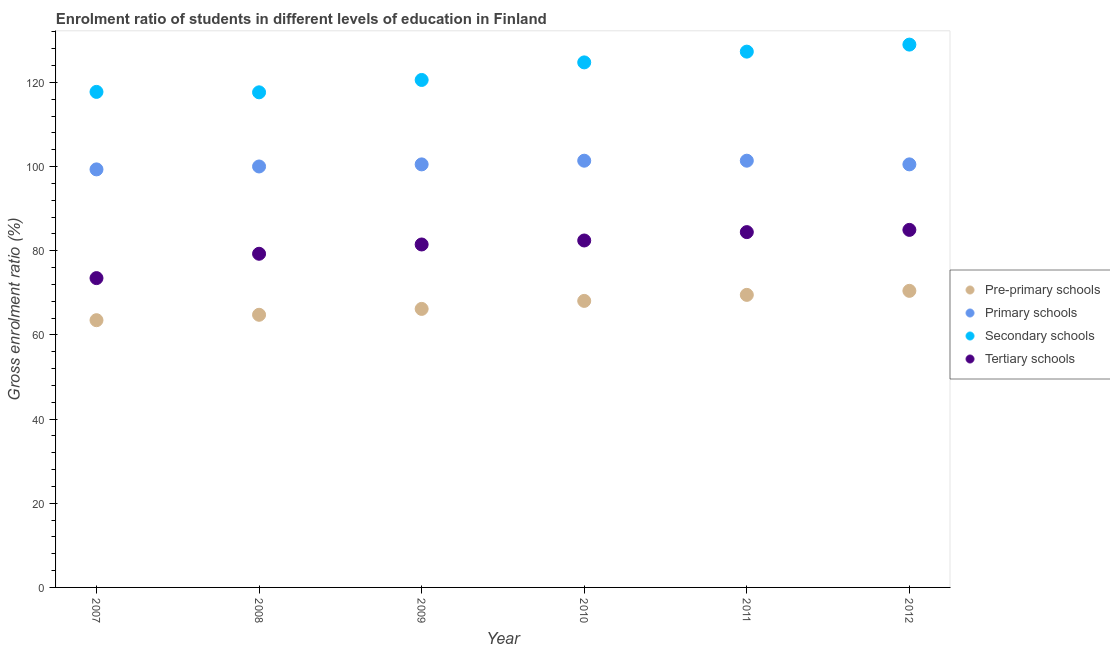How many different coloured dotlines are there?
Provide a short and direct response. 4. Is the number of dotlines equal to the number of legend labels?
Offer a terse response. Yes. What is the gross enrolment ratio in pre-primary schools in 2011?
Offer a terse response. 69.52. Across all years, what is the maximum gross enrolment ratio in pre-primary schools?
Offer a terse response. 70.47. Across all years, what is the minimum gross enrolment ratio in tertiary schools?
Ensure brevity in your answer.  73.5. In which year was the gross enrolment ratio in tertiary schools minimum?
Your answer should be very brief. 2007. What is the total gross enrolment ratio in tertiary schools in the graph?
Your response must be concise. 486.11. What is the difference between the gross enrolment ratio in pre-primary schools in 2007 and that in 2012?
Provide a succinct answer. -6.97. What is the difference between the gross enrolment ratio in primary schools in 2007 and the gross enrolment ratio in tertiary schools in 2010?
Offer a terse response. 16.9. What is the average gross enrolment ratio in primary schools per year?
Keep it short and to the point. 100.54. In the year 2011, what is the difference between the gross enrolment ratio in secondary schools and gross enrolment ratio in pre-primary schools?
Make the answer very short. 57.8. What is the ratio of the gross enrolment ratio in primary schools in 2010 to that in 2012?
Your answer should be very brief. 1.01. Is the gross enrolment ratio in secondary schools in 2010 less than that in 2011?
Give a very brief answer. Yes. Is the difference between the gross enrolment ratio in secondary schools in 2008 and 2009 greater than the difference between the gross enrolment ratio in primary schools in 2008 and 2009?
Give a very brief answer. No. What is the difference between the highest and the second highest gross enrolment ratio in tertiary schools?
Offer a terse response. 0.53. What is the difference between the highest and the lowest gross enrolment ratio in primary schools?
Ensure brevity in your answer.  2.07. Is it the case that in every year, the sum of the gross enrolment ratio in pre-primary schools and gross enrolment ratio in primary schools is greater than the gross enrolment ratio in secondary schools?
Your answer should be very brief. Yes. Does the gross enrolment ratio in secondary schools monotonically increase over the years?
Ensure brevity in your answer.  No. Is the gross enrolment ratio in secondary schools strictly greater than the gross enrolment ratio in tertiary schools over the years?
Give a very brief answer. Yes. Is the gross enrolment ratio in tertiary schools strictly less than the gross enrolment ratio in secondary schools over the years?
Give a very brief answer. Yes. How many years are there in the graph?
Ensure brevity in your answer.  6. Are the values on the major ticks of Y-axis written in scientific E-notation?
Provide a short and direct response. No. Does the graph contain any zero values?
Provide a short and direct response. No. Does the graph contain grids?
Provide a short and direct response. No. What is the title of the graph?
Your response must be concise. Enrolment ratio of students in different levels of education in Finland. What is the label or title of the Y-axis?
Offer a very short reply. Gross enrolment ratio (%). What is the Gross enrolment ratio (%) of Pre-primary schools in 2007?
Your response must be concise. 63.5. What is the Gross enrolment ratio (%) in Primary schools in 2007?
Make the answer very short. 99.33. What is the Gross enrolment ratio (%) of Secondary schools in 2007?
Offer a terse response. 117.75. What is the Gross enrolment ratio (%) of Tertiary schools in 2007?
Provide a short and direct response. 73.5. What is the Gross enrolment ratio (%) of Pre-primary schools in 2008?
Make the answer very short. 64.79. What is the Gross enrolment ratio (%) of Primary schools in 2008?
Provide a succinct answer. 100.03. What is the Gross enrolment ratio (%) in Secondary schools in 2008?
Offer a terse response. 117.65. What is the Gross enrolment ratio (%) in Tertiary schools in 2008?
Ensure brevity in your answer.  79.28. What is the Gross enrolment ratio (%) of Pre-primary schools in 2009?
Give a very brief answer. 66.18. What is the Gross enrolment ratio (%) in Primary schools in 2009?
Offer a very short reply. 100.52. What is the Gross enrolment ratio (%) of Secondary schools in 2009?
Offer a terse response. 120.58. What is the Gross enrolment ratio (%) in Tertiary schools in 2009?
Your response must be concise. 81.49. What is the Gross enrolment ratio (%) in Pre-primary schools in 2010?
Provide a succinct answer. 68.08. What is the Gross enrolment ratio (%) of Primary schools in 2010?
Make the answer very short. 101.4. What is the Gross enrolment ratio (%) in Secondary schools in 2010?
Your answer should be compact. 124.76. What is the Gross enrolment ratio (%) of Tertiary schools in 2010?
Your answer should be very brief. 82.44. What is the Gross enrolment ratio (%) of Pre-primary schools in 2011?
Keep it short and to the point. 69.52. What is the Gross enrolment ratio (%) of Primary schools in 2011?
Ensure brevity in your answer.  101.4. What is the Gross enrolment ratio (%) in Secondary schools in 2011?
Your response must be concise. 127.32. What is the Gross enrolment ratio (%) in Tertiary schools in 2011?
Provide a succinct answer. 84.43. What is the Gross enrolment ratio (%) in Pre-primary schools in 2012?
Make the answer very short. 70.47. What is the Gross enrolment ratio (%) of Primary schools in 2012?
Keep it short and to the point. 100.53. What is the Gross enrolment ratio (%) of Secondary schools in 2012?
Provide a short and direct response. 128.99. What is the Gross enrolment ratio (%) in Tertiary schools in 2012?
Make the answer very short. 84.96. Across all years, what is the maximum Gross enrolment ratio (%) in Pre-primary schools?
Make the answer very short. 70.47. Across all years, what is the maximum Gross enrolment ratio (%) in Primary schools?
Offer a very short reply. 101.4. Across all years, what is the maximum Gross enrolment ratio (%) in Secondary schools?
Your answer should be very brief. 128.99. Across all years, what is the maximum Gross enrolment ratio (%) in Tertiary schools?
Provide a succinct answer. 84.96. Across all years, what is the minimum Gross enrolment ratio (%) of Pre-primary schools?
Give a very brief answer. 63.5. Across all years, what is the minimum Gross enrolment ratio (%) of Primary schools?
Your answer should be very brief. 99.33. Across all years, what is the minimum Gross enrolment ratio (%) in Secondary schools?
Your response must be concise. 117.65. Across all years, what is the minimum Gross enrolment ratio (%) of Tertiary schools?
Offer a very short reply. 73.5. What is the total Gross enrolment ratio (%) in Pre-primary schools in the graph?
Your response must be concise. 402.54. What is the total Gross enrolment ratio (%) of Primary schools in the graph?
Offer a very short reply. 603.21. What is the total Gross enrolment ratio (%) in Secondary schools in the graph?
Keep it short and to the point. 737.04. What is the total Gross enrolment ratio (%) in Tertiary schools in the graph?
Give a very brief answer. 486.11. What is the difference between the Gross enrolment ratio (%) of Pre-primary schools in 2007 and that in 2008?
Make the answer very short. -1.28. What is the difference between the Gross enrolment ratio (%) of Primary schools in 2007 and that in 2008?
Offer a terse response. -0.69. What is the difference between the Gross enrolment ratio (%) in Secondary schools in 2007 and that in 2008?
Keep it short and to the point. 0.1. What is the difference between the Gross enrolment ratio (%) in Tertiary schools in 2007 and that in 2008?
Provide a short and direct response. -5.78. What is the difference between the Gross enrolment ratio (%) in Pre-primary schools in 2007 and that in 2009?
Offer a terse response. -2.68. What is the difference between the Gross enrolment ratio (%) in Primary schools in 2007 and that in 2009?
Provide a succinct answer. -1.19. What is the difference between the Gross enrolment ratio (%) of Secondary schools in 2007 and that in 2009?
Your response must be concise. -2.84. What is the difference between the Gross enrolment ratio (%) in Tertiary schools in 2007 and that in 2009?
Provide a short and direct response. -7.99. What is the difference between the Gross enrolment ratio (%) in Pre-primary schools in 2007 and that in 2010?
Your answer should be very brief. -4.58. What is the difference between the Gross enrolment ratio (%) of Primary schools in 2007 and that in 2010?
Provide a succinct answer. -2.06. What is the difference between the Gross enrolment ratio (%) of Secondary schools in 2007 and that in 2010?
Your answer should be very brief. -7.01. What is the difference between the Gross enrolment ratio (%) of Tertiary schools in 2007 and that in 2010?
Offer a terse response. -8.94. What is the difference between the Gross enrolment ratio (%) of Pre-primary schools in 2007 and that in 2011?
Offer a very short reply. -6.02. What is the difference between the Gross enrolment ratio (%) of Primary schools in 2007 and that in 2011?
Offer a terse response. -2.07. What is the difference between the Gross enrolment ratio (%) in Secondary schools in 2007 and that in 2011?
Offer a very short reply. -9.57. What is the difference between the Gross enrolment ratio (%) in Tertiary schools in 2007 and that in 2011?
Offer a very short reply. -10.93. What is the difference between the Gross enrolment ratio (%) of Pre-primary schools in 2007 and that in 2012?
Keep it short and to the point. -6.97. What is the difference between the Gross enrolment ratio (%) of Primary schools in 2007 and that in 2012?
Your response must be concise. -1.19. What is the difference between the Gross enrolment ratio (%) in Secondary schools in 2007 and that in 2012?
Your answer should be very brief. -11.24. What is the difference between the Gross enrolment ratio (%) in Tertiary schools in 2007 and that in 2012?
Provide a succinct answer. -11.46. What is the difference between the Gross enrolment ratio (%) of Pre-primary schools in 2008 and that in 2009?
Your response must be concise. -1.4. What is the difference between the Gross enrolment ratio (%) in Primary schools in 2008 and that in 2009?
Your response must be concise. -0.5. What is the difference between the Gross enrolment ratio (%) in Secondary schools in 2008 and that in 2009?
Provide a succinct answer. -2.94. What is the difference between the Gross enrolment ratio (%) in Tertiary schools in 2008 and that in 2009?
Provide a short and direct response. -2.21. What is the difference between the Gross enrolment ratio (%) of Pre-primary schools in 2008 and that in 2010?
Provide a short and direct response. -3.3. What is the difference between the Gross enrolment ratio (%) in Primary schools in 2008 and that in 2010?
Keep it short and to the point. -1.37. What is the difference between the Gross enrolment ratio (%) of Secondary schools in 2008 and that in 2010?
Provide a succinct answer. -7.11. What is the difference between the Gross enrolment ratio (%) in Tertiary schools in 2008 and that in 2010?
Make the answer very short. -3.16. What is the difference between the Gross enrolment ratio (%) in Pre-primary schools in 2008 and that in 2011?
Offer a very short reply. -4.73. What is the difference between the Gross enrolment ratio (%) of Primary schools in 2008 and that in 2011?
Provide a short and direct response. -1.37. What is the difference between the Gross enrolment ratio (%) of Secondary schools in 2008 and that in 2011?
Your response must be concise. -9.67. What is the difference between the Gross enrolment ratio (%) of Tertiary schools in 2008 and that in 2011?
Provide a short and direct response. -5.15. What is the difference between the Gross enrolment ratio (%) of Pre-primary schools in 2008 and that in 2012?
Give a very brief answer. -5.69. What is the difference between the Gross enrolment ratio (%) of Primary schools in 2008 and that in 2012?
Make the answer very short. -0.5. What is the difference between the Gross enrolment ratio (%) of Secondary schools in 2008 and that in 2012?
Your answer should be very brief. -11.34. What is the difference between the Gross enrolment ratio (%) of Tertiary schools in 2008 and that in 2012?
Your response must be concise. -5.68. What is the difference between the Gross enrolment ratio (%) in Pre-primary schools in 2009 and that in 2010?
Your response must be concise. -1.9. What is the difference between the Gross enrolment ratio (%) in Primary schools in 2009 and that in 2010?
Ensure brevity in your answer.  -0.88. What is the difference between the Gross enrolment ratio (%) of Secondary schools in 2009 and that in 2010?
Your answer should be compact. -4.17. What is the difference between the Gross enrolment ratio (%) in Tertiary schools in 2009 and that in 2010?
Give a very brief answer. -0.95. What is the difference between the Gross enrolment ratio (%) in Primary schools in 2009 and that in 2011?
Offer a terse response. -0.88. What is the difference between the Gross enrolment ratio (%) of Secondary schools in 2009 and that in 2011?
Provide a succinct answer. -6.73. What is the difference between the Gross enrolment ratio (%) in Tertiary schools in 2009 and that in 2011?
Your answer should be compact. -2.94. What is the difference between the Gross enrolment ratio (%) of Pre-primary schools in 2009 and that in 2012?
Your response must be concise. -4.29. What is the difference between the Gross enrolment ratio (%) of Primary schools in 2009 and that in 2012?
Offer a terse response. -0. What is the difference between the Gross enrolment ratio (%) in Secondary schools in 2009 and that in 2012?
Your response must be concise. -8.4. What is the difference between the Gross enrolment ratio (%) in Tertiary schools in 2009 and that in 2012?
Keep it short and to the point. -3.47. What is the difference between the Gross enrolment ratio (%) of Pre-primary schools in 2010 and that in 2011?
Ensure brevity in your answer.  -1.43. What is the difference between the Gross enrolment ratio (%) in Primary schools in 2010 and that in 2011?
Make the answer very short. -0. What is the difference between the Gross enrolment ratio (%) in Secondary schools in 2010 and that in 2011?
Provide a succinct answer. -2.56. What is the difference between the Gross enrolment ratio (%) in Tertiary schools in 2010 and that in 2011?
Offer a very short reply. -1.99. What is the difference between the Gross enrolment ratio (%) of Pre-primary schools in 2010 and that in 2012?
Your answer should be very brief. -2.39. What is the difference between the Gross enrolment ratio (%) in Primary schools in 2010 and that in 2012?
Provide a short and direct response. 0.87. What is the difference between the Gross enrolment ratio (%) in Secondary schools in 2010 and that in 2012?
Make the answer very short. -4.23. What is the difference between the Gross enrolment ratio (%) of Tertiary schools in 2010 and that in 2012?
Keep it short and to the point. -2.52. What is the difference between the Gross enrolment ratio (%) in Pre-primary schools in 2011 and that in 2012?
Make the answer very short. -0.96. What is the difference between the Gross enrolment ratio (%) of Primary schools in 2011 and that in 2012?
Give a very brief answer. 0.87. What is the difference between the Gross enrolment ratio (%) in Secondary schools in 2011 and that in 2012?
Make the answer very short. -1.67. What is the difference between the Gross enrolment ratio (%) of Tertiary schools in 2011 and that in 2012?
Provide a short and direct response. -0.53. What is the difference between the Gross enrolment ratio (%) in Pre-primary schools in 2007 and the Gross enrolment ratio (%) in Primary schools in 2008?
Offer a terse response. -36.53. What is the difference between the Gross enrolment ratio (%) in Pre-primary schools in 2007 and the Gross enrolment ratio (%) in Secondary schools in 2008?
Your answer should be very brief. -54.15. What is the difference between the Gross enrolment ratio (%) in Pre-primary schools in 2007 and the Gross enrolment ratio (%) in Tertiary schools in 2008?
Offer a terse response. -15.78. What is the difference between the Gross enrolment ratio (%) of Primary schools in 2007 and the Gross enrolment ratio (%) of Secondary schools in 2008?
Provide a succinct answer. -18.31. What is the difference between the Gross enrolment ratio (%) in Primary schools in 2007 and the Gross enrolment ratio (%) in Tertiary schools in 2008?
Make the answer very short. 20.05. What is the difference between the Gross enrolment ratio (%) of Secondary schools in 2007 and the Gross enrolment ratio (%) of Tertiary schools in 2008?
Keep it short and to the point. 38.47. What is the difference between the Gross enrolment ratio (%) of Pre-primary schools in 2007 and the Gross enrolment ratio (%) of Primary schools in 2009?
Make the answer very short. -37.02. What is the difference between the Gross enrolment ratio (%) of Pre-primary schools in 2007 and the Gross enrolment ratio (%) of Secondary schools in 2009?
Your answer should be compact. -57.08. What is the difference between the Gross enrolment ratio (%) in Pre-primary schools in 2007 and the Gross enrolment ratio (%) in Tertiary schools in 2009?
Give a very brief answer. -17.99. What is the difference between the Gross enrolment ratio (%) in Primary schools in 2007 and the Gross enrolment ratio (%) in Secondary schools in 2009?
Ensure brevity in your answer.  -21.25. What is the difference between the Gross enrolment ratio (%) in Primary schools in 2007 and the Gross enrolment ratio (%) in Tertiary schools in 2009?
Provide a succinct answer. 17.84. What is the difference between the Gross enrolment ratio (%) of Secondary schools in 2007 and the Gross enrolment ratio (%) of Tertiary schools in 2009?
Give a very brief answer. 36.26. What is the difference between the Gross enrolment ratio (%) of Pre-primary schools in 2007 and the Gross enrolment ratio (%) of Primary schools in 2010?
Give a very brief answer. -37.9. What is the difference between the Gross enrolment ratio (%) of Pre-primary schools in 2007 and the Gross enrolment ratio (%) of Secondary schools in 2010?
Make the answer very short. -61.26. What is the difference between the Gross enrolment ratio (%) of Pre-primary schools in 2007 and the Gross enrolment ratio (%) of Tertiary schools in 2010?
Provide a short and direct response. -18.94. What is the difference between the Gross enrolment ratio (%) of Primary schools in 2007 and the Gross enrolment ratio (%) of Secondary schools in 2010?
Make the answer very short. -25.42. What is the difference between the Gross enrolment ratio (%) in Primary schools in 2007 and the Gross enrolment ratio (%) in Tertiary schools in 2010?
Offer a very short reply. 16.9. What is the difference between the Gross enrolment ratio (%) in Secondary schools in 2007 and the Gross enrolment ratio (%) in Tertiary schools in 2010?
Provide a succinct answer. 35.31. What is the difference between the Gross enrolment ratio (%) of Pre-primary schools in 2007 and the Gross enrolment ratio (%) of Primary schools in 2011?
Make the answer very short. -37.9. What is the difference between the Gross enrolment ratio (%) of Pre-primary schools in 2007 and the Gross enrolment ratio (%) of Secondary schools in 2011?
Provide a short and direct response. -63.81. What is the difference between the Gross enrolment ratio (%) of Pre-primary schools in 2007 and the Gross enrolment ratio (%) of Tertiary schools in 2011?
Provide a succinct answer. -20.93. What is the difference between the Gross enrolment ratio (%) in Primary schools in 2007 and the Gross enrolment ratio (%) in Secondary schools in 2011?
Your answer should be very brief. -27.98. What is the difference between the Gross enrolment ratio (%) in Primary schools in 2007 and the Gross enrolment ratio (%) in Tertiary schools in 2011?
Ensure brevity in your answer.  14.9. What is the difference between the Gross enrolment ratio (%) of Secondary schools in 2007 and the Gross enrolment ratio (%) of Tertiary schools in 2011?
Make the answer very short. 33.32. What is the difference between the Gross enrolment ratio (%) in Pre-primary schools in 2007 and the Gross enrolment ratio (%) in Primary schools in 2012?
Ensure brevity in your answer.  -37.03. What is the difference between the Gross enrolment ratio (%) of Pre-primary schools in 2007 and the Gross enrolment ratio (%) of Secondary schools in 2012?
Provide a short and direct response. -65.49. What is the difference between the Gross enrolment ratio (%) in Pre-primary schools in 2007 and the Gross enrolment ratio (%) in Tertiary schools in 2012?
Provide a short and direct response. -21.46. What is the difference between the Gross enrolment ratio (%) of Primary schools in 2007 and the Gross enrolment ratio (%) of Secondary schools in 2012?
Your answer should be compact. -29.65. What is the difference between the Gross enrolment ratio (%) in Primary schools in 2007 and the Gross enrolment ratio (%) in Tertiary schools in 2012?
Give a very brief answer. 14.37. What is the difference between the Gross enrolment ratio (%) in Secondary schools in 2007 and the Gross enrolment ratio (%) in Tertiary schools in 2012?
Offer a terse response. 32.79. What is the difference between the Gross enrolment ratio (%) of Pre-primary schools in 2008 and the Gross enrolment ratio (%) of Primary schools in 2009?
Offer a terse response. -35.74. What is the difference between the Gross enrolment ratio (%) of Pre-primary schools in 2008 and the Gross enrolment ratio (%) of Secondary schools in 2009?
Ensure brevity in your answer.  -55.8. What is the difference between the Gross enrolment ratio (%) in Pre-primary schools in 2008 and the Gross enrolment ratio (%) in Tertiary schools in 2009?
Offer a very short reply. -16.71. What is the difference between the Gross enrolment ratio (%) in Primary schools in 2008 and the Gross enrolment ratio (%) in Secondary schools in 2009?
Ensure brevity in your answer.  -20.56. What is the difference between the Gross enrolment ratio (%) of Primary schools in 2008 and the Gross enrolment ratio (%) of Tertiary schools in 2009?
Give a very brief answer. 18.53. What is the difference between the Gross enrolment ratio (%) in Secondary schools in 2008 and the Gross enrolment ratio (%) in Tertiary schools in 2009?
Your answer should be very brief. 36.16. What is the difference between the Gross enrolment ratio (%) in Pre-primary schools in 2008 and the Gross enrolment ratio (%) in Primary schools in 2010?
Offer a very short reply. -36.61. What is the difference between the Gross enrolment ratio (%) of Pre-primary schools in 2008 and the Gross enrolment ratio (%) of Secondary schools in 2010?
Your answer should be compact. -59.97. What is the difference between the Gross enrolment ratio (%) in Pre-primary schools in 2008 and the Gross enrolment ratio (%) in Tertiary schools in 2010?
Ensure brevity in your answer.  -17.65. What is the difference between the Gross enrolment ratio (%) of Primary schools in 2008 and the Gross enrolment ratio (%) of Secondary schools in 2010?
Ensure brevity in your answer.  -24.73. What is the difference between the Gross enrolment ratio (%) of Primary schools in 2008 and the Gross enrolment ratio (%) of Tertiary schools in 2010?
Ensure brevity in your answer.  17.59. What is the difference between the Gross enrolment ratio (%) of Secondary schools in 2008 and the Gross enrolment ratio (%) of Tertiary schools in 2010?
Offer a terse response. 35.21. What is the difference between the Gross enrolment ratio (%) in Pre-primary schools in 2008 and the Gross enrolment ratio (%) in Primary schools in 2011?
Keep it short and to the point. -36.62. What is the difference between the Gross enrolment ratio (%) in Pre-primary schools in 2008 and the Gross enrolment ratio (%) in Secondary schools in 2011?
Offer a terse response. -62.53. What is the difference between the Gross enrolment ratio (%) in Pre-primary schools in 2008 and the Gross enrolment ratio (%) in Tertiary schools in 2011?
Offer a very short reply. -19.65. What is the difference between the Gross enrolment ratio (%) in Primary schools in 2008 and the Gross enrolment ratio (%) in Secondary schools in 2011?
Offer a terse response. -27.29. What is the difference between the Gross enrolment ratio (%) in Primary schools in 2008 and the Gross enrolment ratio (%) in Tertiary schools in 2011?
Your response must be concise. 15.6. What is the difference between the Gross enrolment ratio (%) of Secondary schools in 2008 and the Gross enrolment ratio (%) of Tertiary schools in 2011?
Offer a very short reply. 33.22. What is the difference between the Gross enrolment ratio (%) of Pre-primary schools in 2008 and the Gross enrolment ratio (%) of Primary schools in 2012?
Your answer should be compact. -35.74. What is the difference between the Gross enrolment ratio (%) in Pre-primary schools in 2008 and the Gross enrolment ratio (%) in Secondary schools in 2012?
Provide a short and direct response. -64.2. What is the difference between the Gross enrolment ratio (%) of Pre-primary schools in 2008 and the Gross enrolment ratio (%) of Tertiary schools in 2012?
Give a very brief answer. -20.18. What is the difference between the Gross enrolment ratio (%) of Primary schools in 2008 and the Gross enrolment ratio (%) of Secondary schools in 2012?
Your answer should be very brief. -28.96. What is the difference between the Gross enrolment ratio (%) in Primary schools in 2008 and the Gross enrolment ratio (%) in Tertiary schools in 2012?
Your response must be concise. 15.07. What is the difference between the Gross enrolment ratio (%) in Secondary schools in 2008 and the Gross enrolment ratio (%) in Tertiary schools in 2012?
Provide a short and direct response. 32.69. What is the difference between the Gross enrolment ratio (%) of Pre-primary schools in 2009 and the Gross enrolment ratio (%) of Primary schools in 2010?
Provide a succinct answer. -35.22. What is the difference between the Gross enrolment ratio (%) in Pre-primary schools in 2009 and the Gross enrolment ratio (%) in Secondary schools in 2010?
Ensure brevity in your answer.  -58.58. What is the difference between the Gross enrolment ratio (%) in Pre-primary schools in 2009 and the Gross enrolment ratio (%) in Tertiary schools in 2010?
Keep it short and to the point. -16.26. What is the difference between the Gross enrolment ratio (%) of Primary schools in 2009 and the Gross enrolment ratio (%) of Secondary schools in 2010?
Offer a very short reply. -24.24. What is the difference between the Gross enrolment ratio (%) of Primary schools in 2009 and the Gross enrolment ratio (%) of Tertiary schools in 2010?
Your answer should be compact. 18.08. What is the difference between the Gross enrolment ratio (%) in Secondary schools in 2009 and the Gross enrolment ratio (%) in Tertiary schools in 2010?
Ensure brevity in your answer.  38.15. What is the difference between the Gross enrolment ratio (%) of Pre-primary schools in 2009 and the Gross enrolment ratio (%) of Primary schools in 2011?
Offer a terse response. -35.22. What is the difference between the Gross enrolment ratio (%) of Pre-primary schools in 2009 and the Gross enrolment ratio (%) of Secondary schools in 2011?
Provide a short and direct response. -61.13. What is the difference between the Gross enrolment ratio (%) in Pre-primary schools in 2009 and the Gross enrolment ratio (%) in Tertiary schools in 2011?
Your answer should be very brief. -18.25. What is the difference between the Gross enrolment ratio (%) of Primary schools in 2009 and the Gross enrolment ratio (%) of Secondary schools in 2011?
Your answer should be very brief. -26.79. What is the difference between the Gross enrolment ratio (%) of Primary schools in 2009 and the Gross enrolment ratio (%) of Tertiary schools in 2011?
Give a very brief answer. 16.09. What is the difference between the Gross enrolment ratio (%) in Secondary schools in 2009 and the Gross enrolment ratio (%) in Tertiary schools in 2011?
Provide a succinct answer. 36.15. What is the difference between the Gross enrolment ratio (%) in Pre-primary schools in 2009 and the Gross enrolment ratio (%) in Primary schools in 2012?
Offer a terse response. -34.34. What is the difference between the Gross enrolment ratio (%) in Pre-primary schools in 2009 and the Gross enrolment ratio (%) in Secondary schools in 2012?
Offer a terse response. -62.8. What is the difference between the Gross enrolment ratio (%) in Pre-primary schools in 2009 and the Gross enrolment ratio (%) in Tertiary schools in 2012?
Offer a terse response. -18.78. What is the difference between the Gross enrolment ratio (%) in Primary schools in 2009 and the Gross enrolment ratio (%) in Secondary schools in 2012?
Give a very brief answer. -28.46. What is the difference between the Gross enrolment ratio (%) of Primary schools in 2009 and the Gross enrolment ratio (%) of Tertiary schools in 2012?
Ensure brevity in your answer.  15.56. What is the difference between the Gross enrolment ratio (%) of Secondary schools in 2009 and the Gross enrolment ratio (%) of Tertiary schools in 2012?
Keep it short and to the point. 35.62. What is the difference between the Gross enrolment ratio (%) in Pre-primary schools in 2010 and the Gross enrolment ratio (%) in Primary schools in 2011?
Give a very brief answer. -33.32. What is the difference between the Gross enrolment ratio (%) of Pre-primary schools in 2010 and the Gross enrolment ratio (%) of Secondary schools in 2011?
Make the answer very short. -59.23. What is the difference between the Gross enrolment ratio (%) of Pre-primary schools in 2010 and the Gross enrolment ratio (%) of Tertiary schools in 2011?
Give a very brief answer. -16.35. What is the difference between the Gross enrolment ratio (%) of Primary schools in 2010 and the Gross enrolment ratio (%) of Secondary schools in 2011?
Ensure brevity in your answer.  -25.92. What is the difference between the Gross enrolment ratio (%) in Primary schools in 2010 and the Gross enrolment ratio (%) in Tertiary schools in 2011?
Your answer should be compact. 16.97. What is the difference between the Gross enrolment ratio (%) in Secondary schools in 2010 and the Gross enrolment ratio (%) in Tertiary schools in 2011?
Keep it short and to the point. 40.33. What is the difference between the Gross enrolment ratio (%) in Pre-primary schools in 2010 and the Gross enrolment ratio (%) in Primary schools in 2012?
Keep it short and to the point. -32.44. What is the difference between the Gross enrolment ratio (%) of Pre-primary schools in 2010 and the Gross enrolment ratio (%) of Secondary schools in 2012?
Keep it short and to the point. -60.9. What is the difference between the Gross enrolment ratio (%) of Pre-primary schools in 2010 and the Gross enrolment ratio (%) of Tertiary schools in 2012?
Give a very brief answer. -16.88. What is the difference between the Gross enrolment ratio (%) in Primary schools in 2010 and the Gross enrolment ratio (%) in Secondary schools in 2012?
Offer a very short reply. -27.59. What is the difference between the Gross enrolment ratio (%) of Primary schools in 2010 and the Gross enrolment ratio (%) of Tertiary schools in 2012?
Make the answer very short. 16.44. What is the difference between the Gross enrolment ratio (%) of Secondary schools in 2010 and the Gross enrolment ratio (%) of Tertiary schools in 2012?
Make the answer very short. 39.8. What is the difference between the Gross enrolment ratio (%) of Pre-primary schools in 2011 and the Gross enrolment ratio (%) of Primary schools in 2012?
Provide a short and direct response. -31.01. What is the difference between the Gross enrolment ratio (%) of Pre-primary schools in 2011 and the Gross enrolment ratio (%) of Secondary schools in 2012?
Your response must be concise. -59.47. What is the difference between the Gross enrolment ratio (%) of Pre-primary schools in 2011 and the Gross enrolment ratio (%) of Tertiary schools in 2012?
Provide a succinct answer. -15.44. What is the difference between the Gross enrolment ratio (%) of Primary schools in 2011 and the Gross enrolment ratio (%) of Secondary schools in 2012?
Give a very brief answer. -27.59. What is the difference between the Gross enrolment ratio (%) of Primary schools in 2011 and the Gross enrolment ratio (%) of Tertiary schools in 2012?
Provide a short and direct response. 16.44. What is the difference between the Gross enrolment ratio (%) in Secondary schools in 2011 and the Gross enrolment ratio (%) in Tertiary schools in 2012?
Offer a very short reply. 42.35. What is the average Gross enrolment ratio (%) of Pre-primary schools per year?
Your answer should be very brief. 67.09. What is the average Gross enrolment ratio (%) in Primary schools per year?
Give a very brief answer. 100.54. What is the average Gross enrolment ratio (%) of Secondary schools per year?
Make the answer very short. 122.84. What is the average Gross enrolment ratio (%) in Tertiary schools per year?
Your answer should be very brief. 81.02. In the year 2007, what is the difference between the Gross enrolment ratio (%) of Pre-primary schools and Gross enrolment ratio (%) of Primary schools?
Ensure brevity in your answer.  -35.83. In the year 2007, what is the difference between the Gross enrolment ratio (%) of Pre-primary schools and Gross enrolment ratio (%) of Secondary schools?
Provide a short and direct response. -54.25. In the year 2007, what is the difference between the Gross enrolment ratio (%) in Pre-primary schools and Gross enrolment ratio (%) in Tertiary schools?
Your answer should be compact. -10. In the year 2007, what is the difference between the Gross enrolment ratio (%) of Primary schools and Gross enrolment ratio (%) of Secondary schools?
Offer a very short reply. -18.41. In the year 2007, what is the difference between the Gross enrolment ratio (%) of Primary schools and Gross enrolment ratio (%) of Tertiary schools?
Offer a terse response. 25.84. In the year 2007, what is the difference between the Gross enrolment ratio (%) of Secondary schools and Gross enrolment ratio (%) of Tertiary schools?
Offer a terse response. 44.25. In the year 2008, what is the difference between the Gross enrolment ratio (%) of Pre-primary schools and Gross enrolment ratio (%) of Primary schools?
Provide a short and direct response. -35.24. In the year 2008, what is the difference between the Gross enrolment ratio (%) of Pre-primary schools and Gross enrolment ratio (%) of Secondary schools?
Offer a very short reply. -52.86. In the year 2008, what is the difference between the Gross enrolment ratio (%) in Pre-primary schools and Gross enrolment ratio (%) in Tertiary schools?
Ensure brevity in your answer.  -14.5. In the year 2008, what is the difference between the Gross enrolment ratio (%) in Primary schools and Gross enrolment ratio (%) in Secondary schools?
Your response must be concise. -17.62. In the year 2008, what is the difference between the Gross enrolment ratio (%) of Primary schools and Gross enrolment ratio (%) of Tertiary schools?
Ensure brevity in your answer.  20.74. In the year 2008, what is the difference between the Gross enrolment ratio (%) of Secondary schools and Gross enrolment ratio (%) of Tertiary schools?
Offer a terse response. 38.36. In the year 2009, what is the difference between the Gross enrolment ratio (%) in Pre-primary schools and Gross enrolment ratio (%) in Primary schools?
Make the answer very short. -34.34. In the year 2009, what is the difference between the Gross enrolment ratio (%) in Pre-primary schools and Gross enrolment ratio (%) in Secondary schools?
Your answer should be very brief. -54.4. In the year 2009, what is the difference between the Gross enrolment ratio (%) of Pre-primary schools and Gross enrolment ratio (%) of Tertiary schools?
Make the answer very short. -15.31. In the year 2009, what is the difference between the Gross enrolment ratio (%) in Primary schools and Gross enrolment ratio (%) in Secondary schools?
Your answer should be compact. -20.06. In the year 2009, what is the difference between the Gross enrolment ratio (%) in Primary schools and Gross enrolment ratio (%) in Tertiary schools?
Your answer should be compact. 19.03. In the year 2009, what is the difference between the Gross enrolment ratio (%) of Secondary schools and Gross enrolment ratio (%) of Tertiary schools?
Keep it short and to the point. 39.09. In the year 2010, what is the difference between the Gross enrolment ratio (%) in Pre-primary schools and Gross enrolment ratio (%) in Primary schools?
Provide a short and direct response. -33.31. In the year 2010, what is the difference between the Gross enrolment ratio (%) of Pre-primary schools and Gross enrolment ratio (%) of Secondary schools?
Offer a very short reply. -56.67. In the year 2010, what is the difference between the Gross enrolment ratio (%) of Pre-primary schools and Gross enrolment ratio (%) of Tertiary schools?
Offer a very short reply. -14.35. In the year 2010, what is the difference between the Gross enrolment ratio (%) of Primary schools and Gross enrolment ratio (%) of Secondary schools?
Provide a short and direct response. -23.36. In the year 2010, what is the difference between the Gross enrolment ratio (%) of Primary schools and Gross enrolment ratio (%) of Tertiary schools?
Your response must be concise. 18.96. In the year 2010, what is the difference between the Gross enrolment ratio (%) in Secondary schools and Gross enrolment ratio (%) in Tertiary schools?
Your answer should be very brief. 42.32. In the year 2011, what is the difference between the Gross enrolment ratio (%) in Pre-primary schools and Gross enrolment ratio (%) in Primary schools?
Offer a terse response. -31.88. In the year 2011, what is the difference between the Gross enrolment ratio (%) in Pre-primary schools and Gross enrolment ratio (%) in Secondary schools?
Provide a short and direct response. -57.8. In the year 2011, what is the difference between the Gross enrolment ratio (%) of Pre-primary schools and Gross enrolment ratio (%) of Tertiary schools?
Make the answer very short. -14.91. In the year 2011, what is the difference between the Gross enrolment ratio (%) in Primary schools and Gross enrolment ratio (%) in Secondary schools?
Offer a terse response. -25.91. In the year 2011, what is the difference between the Gross enrolment ratio (%) in Primary schools and Gross enrolment ratio (%) in Tertiary schools?
Provide a short and direct response. 16.97. In the year 2011, what is the difference between the Gross enrolment ratio (%) in Secondary schools and Gross enrolment ratio (%) in Tertiary schools?
Your response must be concise. 42.88. In the year 2012, what is the difference between the Gross enrolment ratio (%) of Pre-primary schools and Gross enrolment ratio (%) of Primary schools?
Ensure brevity in your answer.  -30.05. In the year 2012, what is the difference between the Gross enrolment ratio (%) in Pre-primary schools and Gross enrolment ratio (%) in Secondary schools?
Make the answer very short. -58.51. In the year 2012, what is the difference between the Gross enrolment ratio (%) of Pre-primary schools and Gross enrolment ratio (%) of Tertiary schools?
Your answer should be compact. -14.49. In the year 2012, what is the difference between the Gross enrolment ratio (%) in Primary schools and Gross enrolment ratio (%) in Secondary schools?
Provide a short and direct response. -28.46. In the year 2012, what is the difference between the Gross enrolment ratio (%) in Primary schools and Gross enrolment ratio (%) in Tertiary schools?
Provide a short and direct response. 15.57. In the year 2012, what is the difference between the Gross enrolment ratio (%) of Secondary schools and Gross enrolment ratio (%) of Tertiary schools?
Provide a succinct answer. 44.03. What is the ratio of the Gross enrolment ratio (%) in Pre-primary schools in 2007 to that in 2008?
Ensure brevity in your answer.  0.98. What is the ratio of the Gross enrolment ratio (%) in Secondary schools in 2007 to that in 2008?
Give a very brief answer. 1. What is the ratio of the Gross enrolment ratio (%) of Tertiary schools in 2007 to that in 2008?
Offer a terse response. 0.93. What is the ratio of the Gross enrolment ratio (%) of Pre-primary schools in 2007 to that in 2009?
Provide a short and direct response. 0.96. What is the ratio of the Gross enrolment ratio (%) in Primary schools in 2007 to that in 2009?
Your response must be concise. 0.99. What is the ratio of the Gross enrolment ratio (%) of Secondary schools in 2007 to that in 2009?
Offer a terse response. 0.98. What is the ratio of the Gross enrolment ratio (%) of Tertiary schools in 2007 to that in 2009?
Make the answer very short. 0.9. What is the ratio of the Gross enrolment ratio (%) of Pre-primary schools in 2007 to that in 2010?
Your response must be concise. 0.93. What is the ratio of the Gross enrolment ratio (%) of Primary schools in 2007 to that in 2010?
Keep it short and to the point. 0.98. What is the ratio of the Gross enrolment ratio (%) of Secondary schools in 2007 to that in 2010?
Give a very brief answer. 0.94. What is the ratio of the Gross enrolment ratio (%) in Tertiary schools in 2007 to that in 2010?
Provide a succinct answer. 0.89. What is the ratio of the Gross enrolment ratio (%) of Pre-primary schools in 2007 to that in 2011?
Make the answer very short. 0.91. What is the ratio of the Gross enrolment ratio (%) of Primary schools in 2007 to that in 2011?
Give a very brief answer. 0.98. What is the ratio of the Gross enrolment ratio (%) in Secondary schools in 2007 to that in 2011?
Your response must be concise. 0.92. What is the ratio of the Gross enrolment ratio (%) in Tertiary schools in 2007 to that in 2011?
Provide a succinct answer. 0.87. What is the ratio of the Gross enrolment ratio (%) in Pre-primary schools in 2007 to that in 2012?
Ensure brevity in your answer.  0.9. What is the ratio of the Gross enrolment ratio (%) of Primary schools in 2007 to that in 2012?
Your response must be concise. 0.99. What is the ratio of the Gross enrolment ratio (%) in Secondary schools in 2007 to that in 2012?
Your answer should be very brief. 0.91. What is the ratio of the Gross enrolment ratio (%) of Tertiary schools in 2007 to that in 2012?
Provide a short and direct response. 0.87. What is the ratio of the Gross enrolment ratio (%) of Pre-primary schools in 2008 to that in 2009?
Offer a terse response. 0.98. What is the ratio of the Gross enrolment ratio (%) of Primary schools in 2008 to that in 2009?
Give a very brief answer. 1. What is the ratio of the Gross enrolment ratio (%) in Secondary schools in 2008 to that in 2009?
Provide a short and direct response. 0.98. What is the ratio of the Gross enrolment ratio (%) in Tertiary schools in 2008 to that in 2009?
Provide a short and direct response. 0.97. What is the ratio of the Gross enrolment ratio (%) in Pre-primary schools in 2008 to that in 2010?
Your response must be concise. 0.95. What is the ratio of the Gross enrolment ratio (%) of Primary schools in 2008 to that in 2010?
Your answer should be very brief. 0.99. What is the ratio of the Gross enrolment ratio (%) of Secondary schools in 2008 to that in 2010?
Provide a short and direct response. 0.94. What is the ratio of the Gross enrolment ratio (%) in Tertiary schools in 2008 to that in 2010?
Give a very brief answer. 0.96. What is the ratio of the Gross enrolment ratio (%) of Pre-primary schools in 2008 to that in 2011?
Provide a short and direct response. 0.93. What is the ratio of the Gross enrolment ratio (%) in Primary schools in 2008 to that in 2011?
Provide a succinct answer. 0.99. What is the ratio of the Gross enrolment ratio (%) of Secondary schools in 2008 to that in 2011?
Your answer should be very brief. 0.92. What is the ratio of the Gross enrolment ratio (%) in Tertiary schools in 2008 to that in 2011?
Make the answer very short. 0.94. What is the ratio of the Gross enrolment ratio (%) of Pre-primary schools in 2008 to that in 2012?
Provide a succinct answer. 0.92. What is the ratio of the Gross enrolment ratio (%) of Secondary schools in 2008 to that in 2012?
Provide a succinct answer. 0.91. What is the ratio of the Gross enrolment ratio (%) in Tertiary schools in 2008 to that in 2012?
Provide a succinct answer. 0.93. What is the ratio of the Gross enrolment ratio (%) in Pre-primary schools in 2009 to that in 2010?
Give a very brief answer. 0.97. What is the ratio of the Gross enrolment ratio (%) in Primary schools in 2009 to that in 2010?
Your answer should be very brief. 0.99. What is the ratio of the Gross enrolment ratio (%) in Secondary schools in 2009 to that in 2010?
Offer a terse response. 0.97. What is the ratio of the Gross enrolment ratio (%) in Tertiary schools in 2009 to that in 2010?
Your answer should be compact. 0.99. What is the ratio of the Gross enrolment ratio (%) of Pre-primary schools in 2009 to that in 2011?
Keep it short and to the point. 0.95. What is the ratio of the Gross enrolment ratio (%) in Primary schools in 2009 to that in 2011?
Make the answer very short. 0.99. What is the ratio of the Gross enrolment ratio (%) in Secondary schools in 2009 to that in 2011?
Keep it short and to the point. 0.95. What is the ratio of the Gross enrolment ratio (%) in Tertiary schools in 2009 to that in 2011?
Provide a short and direct response. 0.97. What is the ratio of the Gross enrolment ratio (%) in Pre-primary schools in 2009 to that in 2012?
Provide a short and direct response. 0.94. What is the ratio of the Gross enrolment ratio (%) in Secondary schools in 2009 to that in 2012?
Keep it short and to the point. 0.93. What is the ratio of the Gross enrolment ratio (%) in Tertiary schools in 2009 to that in 2012?
Your answer should be very brief. 0.96. What is the ratio of the Gross enrolment ratio (%) in Pre-primary schools in 2010 to that in 2011?
Your answer should be compact. 0.98. What is the ratio of the Gross enrolment ratio (%) in Primary schools in 2010 to that in 2011?
Ensure brevity in your answer.  1. What is the ratio of the Gross enrolment ratio (%) of Secondary schools in 2010 to that in 2011?
Your response must be concise. 0.98. What is the ratio of the Gross enrolment ratio (%) in Tertiary schools in 2010 to that in 2011?
Give a very brief answer. 0.98. What is the ratio of the Gross enrolment ratio (%) of Pre-primary schools in 2010 to that in 2012?
Your response must be concise. 0.97. What is the ratio of the Gross enrolment ratio (%) in Primary schools in 2010 to that in 2012?
Make the answer very short. 1.01. What is the ratio of the Gross enrolment ratio (%) of Secondary schools in 2010 to that in 2012?
Your answer should be very brief. 0.97. What is the ratio of the Gross enrolment ratio (%) in Tertiary schools in 2010 to that in 2012?
Your answer should be very brief. 0.97. What is the ratio of the Gross enrolment ratio (%) of Pre-primary schools in 2011 to that in 2012?
Give a very brief answer. 0.99. What is the ratio of the Gross enrolment ratio (%) in Primary schools in 2011 to that in 2012?
Provide a short and direct response. 1.01. What is the ratio of the Gross enrolment ratio (%) of Secondary schools in 2011 to that in 2012?
Your answer should be compact. 0.99. What is the difference between the highest and the second highest Gross enrolment ratio (%) of Pre-primary schools?
Make the answer very short. 0.96. What is the difference between the highest and the second highest Gross enrolment ratio (%) of Primary schools?
Your answer should be compact. 0. What is the difference between the highest and the second highest Gross enrolment ratio (%) of Secondary schools?
Your answer should be very brief. 1.67. What is the difference between the highest and the second highest Gross enrolment ratio (%) of Tertiary schools?
Your answer should be compact. 0.53. What is the difference between the highest and the lowest Gross enrolment ratio (%) in Pre-primary schools?
Ensure brevity in your answer.  6.97. What is the difference between the highest and the lowest Gross enrolment ratio (%) in Primary schools?
Make the answer very short. 2.07. What is the difference between the highest and the lowest Gross enrolment ratio (%) in Secondary schools?
Provide a succinct answer. 11.34. What is the difference between the highest and the lowest Gross enrolment ratio (%) in Tertiary schools?
Your answer should be compact. 11.46. 